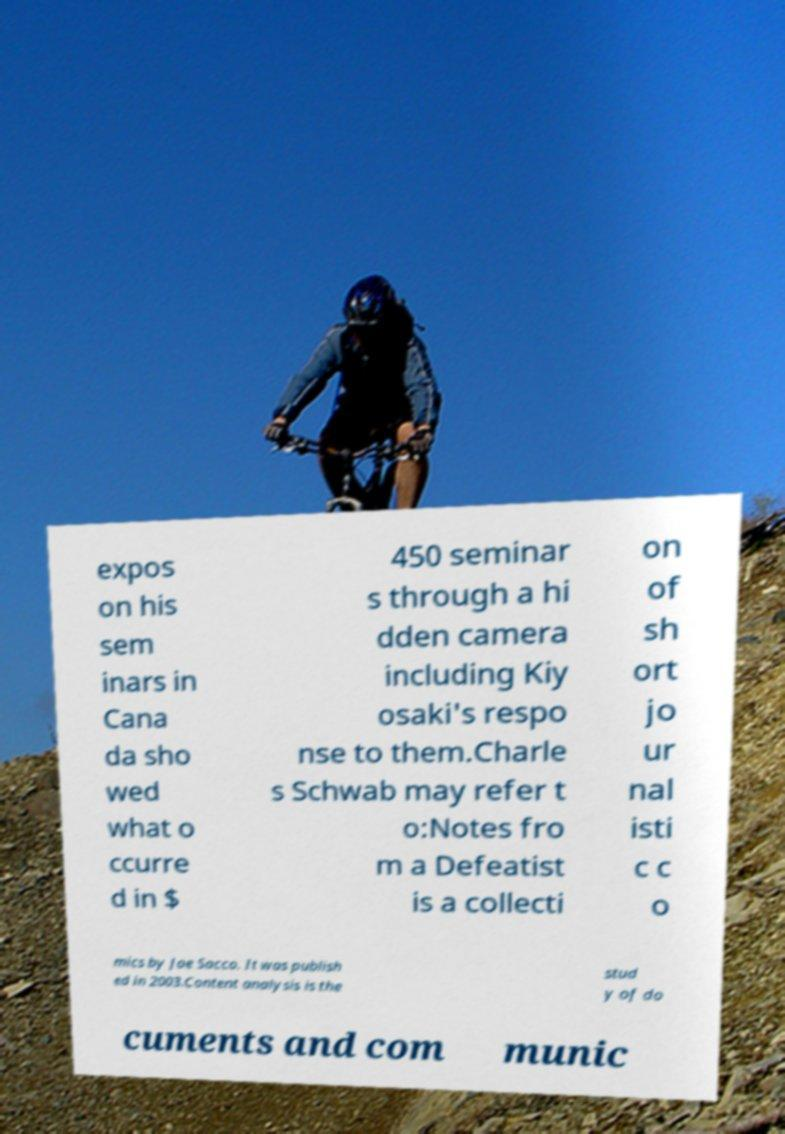What messages or text are displayed in this image? I need them in a readable, typed format. expos on his sem inars in Cana da sho wed what o ccurre d in $ 450 seminar s through a hi dden camera including Kiy osaki's respo nse to them.Charle s Schwab may refer t o:Notes fro m a Defeatist is a collecti on of sh ort jo ur nal isti c c o mics by Joe Sacco. It was publish ed in 2003.Content analysis is the stud y of do cuments and com munic 